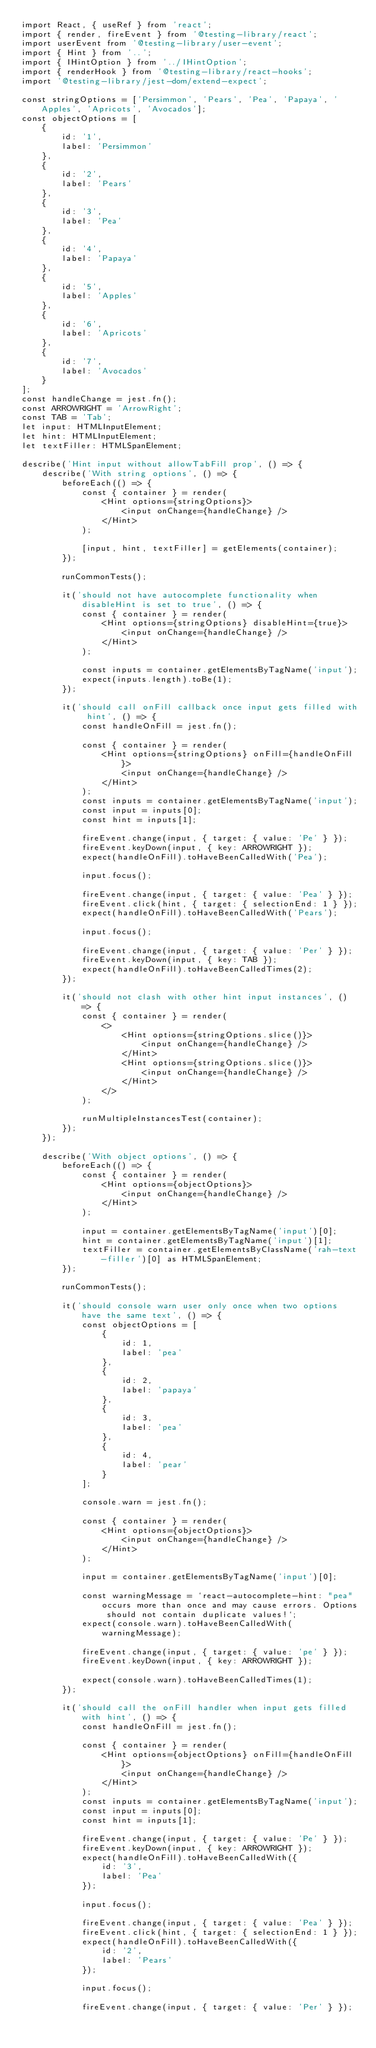<code> <loc_0><loc_0><loc_500><loc_500><_TypeScript_>import React, { useRef } from 'react';
import { render, fireEvent } from '@testing-library/react';
import userEvent from '@testing-library/user-event';
import { Hint } from '..';
import { IHintOption } from '../IHintOption';
import { renderHook } from '@testing-library/react-hooks';
import '@testing-library/jest-dom/extend-expect';

const stringOptions = ['Persimmon', 'Pears', 'Pea', 'Papaya', 'Apples', 'Apricots', 'Avocados'];
const objectOptions = [
    {
        id: '1',
        label: 'Persimmon'
    },
    {
        id: '2',
        label: 'Pears'
    },
    {
        id: '3',
        label: 'Pea'
    },
    {
        id: '4',
        label: 'Papaya'
    },
    {
        id: '5',
        label: 'Apples'
    },
    {
        id: '6',
        label: 'Apricots'
    },
    {
        id: '7',
        label: 'Avocados'
    }
];
const handleChange = jest.fn();
const ARROWRIGHT = 'ArrowRight';
const TAB = 'Tab';
let input: HTMLInputElement;
let hint: HTMLInputElement;
let textFiller: HTMLSpanElement;

describe('Hint input without allowTabFill prop', () => {
    describe('With string options', () => {
        beforeEach(() => {
            const { container } = render(
                <Hint options={stringOptions}>
                    <input onChange={handleChange} />
                </Hint>
            );

            [input, hint, textFiller] = getElements(container);
        });

        runCommonTests();

        it('should not have autocomplete functionality when disableHint is set to true', () => {
            const { container } = render(
                <Hint options={stringOptions} disableHint={true}>
                    <input onChange={handleChange} />
                </Hint>
            );

            const inputs = container.getElementsByTagName('input');
            expect(inputs.length).toBe(1);
        });

        it('should call onFill callback once input gets filled with hint', () => {
            const handleOnFill = jest.fn();

            const { container } = render(
                <Hint options={stringOptions} onFill={handleOnFill}>
                    <input onChange={handleChange} />
                </Hint>
            );
            const inputs = container.getElementsByTagName('input');
            const input = inputs[0];
            const hint = inputs[1];

            fireEvent.change(input, { target: { value: 'Pe' } });
            fireEvent.keyDown(input, { key: ARROWRIGHT });
            expect(handleOnFill).toHaveBeenCalledWith('Pea');

            input.focus();

            fireEvent.change(input, { target: { value: 'Pea' } });
            fireEvent.click(hint, { target: { selectionEnd: 1 } });
            expect(handleOnFill).toHaveBeenCalledWith('Pears');

            input.focus();

            fireEvent.change(input, { target: { value: 'Per' } });
            fireEvent.keyDown(input, { key: TAB });
            expect(handleOnFill).toHaveBeenCalledTimes(2);
        });

        it('should not clash with other hint input instances', () => {
            const { container } = render(
                <>
                    <Hint options={stringOptions.slice()}>
                        <input onChange={handleChange} />
                    </Hint>
                    <Hint options={stringOptions.slice()}>
                        <input onChange={handleChange} />
                    </Hint>
                </>
            );

            runMultipleInstancesTest(container);
        });
    });

    describe('With object options', () => {
        beforeEach(() => {
            const { container } = render(
                <Hint options={objectOptions}>
                    <input onChange={handleChange} />
                </Hint>
            );

            input = container.getElementsByTagName('input')[0];
            hint = container.getElementsByTagName('input')[1];
            textFiller = container.getElementsByClassName('rah-text-filler')[0] as HTMLSpanElement;
        });

        runCommonTests();

        it('should console warn user only once when two options have the same text', () => {
            const objectOptions = [
                {
                    id: 1,
                    label: 'pea'
                },
                {
                    id: 2,
                    label: 'papaya'
                },
                {
                    id: 3,
                    label: 'pea'
                },
                {
                    id: 4,
                    label: 'pear'
                }
            ];

            console.warn = jest.fn();

            const { container } = render(
                <Hint options={objectOptions}>
                    <input onChange={handleChange} />
                </Hint>
            );

            input = container.getElementsByTagName('input')[0];

            const warningMessage = `react-autocomplete-hint: "pea" occurs more than once and may cause errors. Options should not contain duplicate values!`;
            expect(console.warn).toHaveBeenCalledWith(warningMessage);

            fireEvent.change(input, { target: { value: 'pe' } });
            fireEvent.keyDown(input, { key: ARROWRIGHT });

            expect(console.warn).toHaveBeenCalledTimes(1);
        });

        it('should call the onFill handler when input gets filled with hint', () => {
            const handleOnFill = jest.fn();

            const { container } = render(
                <Hint options={objectOptions} onFill={handleOnFill}>
                    <input onChange={handleChange} />
                </Hint>
            );
            const inputs = container.getElementsByTagName('input');
            const input = inputs[0];
            const hint = inputs[1];

            fireEvent.change(input, { target: { value: 'Pe' } });
            fireEvent.keyDown(input, { key: ARROWRIGHT });
            expect(handleOnFill).toHaveBeenCalledWith({
                id: '3',
                label: 'Pea'
            });

            input.focus();

            fireEvent.change(input, { target: { value: 'Pea' } });
            fireEvent.click(hint, { target: { selectionEnd: 1 } });
            expect(handleOnFill).toHaveBeenCalledWith({
                id: '2',
                label: 'Pears'
            });

            input.focus();

            fireEvent.change(input, { target: { value: 'Per' } });</code> 